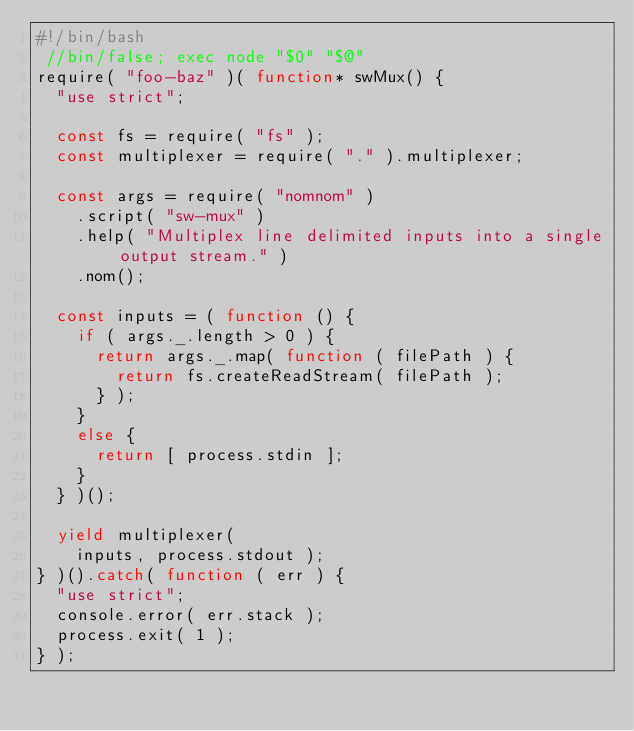<code> <loc_0><loc_0><loc_500><loc_500><_JavaScript_>#!/bin/bash
 //bin/false; exec node "$0" "$@"
require( "foo-baz" )( function* swMux() {
	"use strict";

	const fs = require( "fs" );
	const multiplexer = require( "." ).multiplexer;

	const args = require( "nomnom" )
		.script( "sw-mux" )
		.help( "Multiplex line delimited inputs into a single output stream." )
		.nom();

	const inputs = ( function () {
		if ( args._.length > 0 ) {
			return args._.map( function ( filePath ) {
				return fs.createReadStream( filePath );
			} );
		}
		else {
			return [ process.stdin ];
		}
	} )();

	yield multiplexer(
		inputs, process.stdout );
} )().catch( function ( err ) {
	"use strict";
	console.error( err.stack );
	process.exit( 1 );
} );</code> 